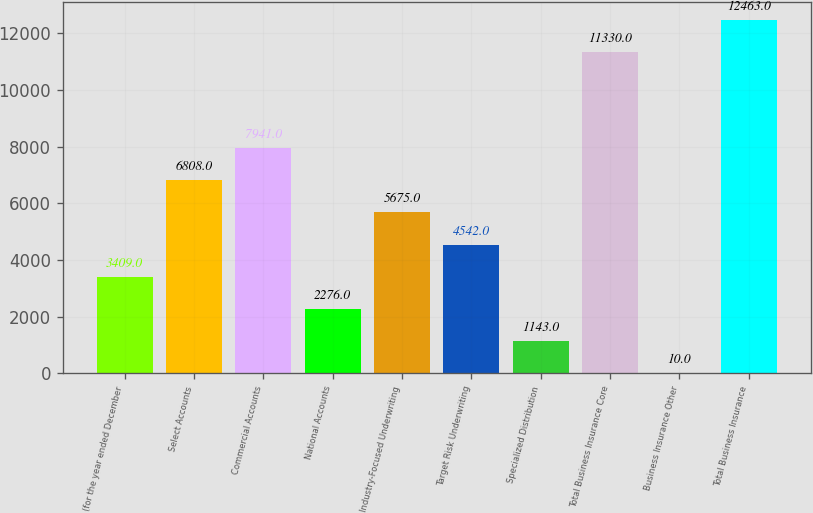Convert chart to OTSL. <chart><loc_0><loc_0><loc_500><loc_500><bar_chart><fcel>(for the year ended December<fcel>Select Accounts<fcel>Commercial Accounts<fcel>National Accounts<fcel>Industry-Focused Underwriting<fcel>Target Risk Underwriting<fcel>Specialized Distribution<fcel>Total Business Insurance Core<fcel>Business Insurance Other<fcel>Total Business Insurance<nl><fcel>3409<fcel>6808<fcel>7941<fcel>2276<fcel>5675<fcel>4542<fcel>1143<fcel>11330<fcel>10<fcel>12463<nl></chart> 